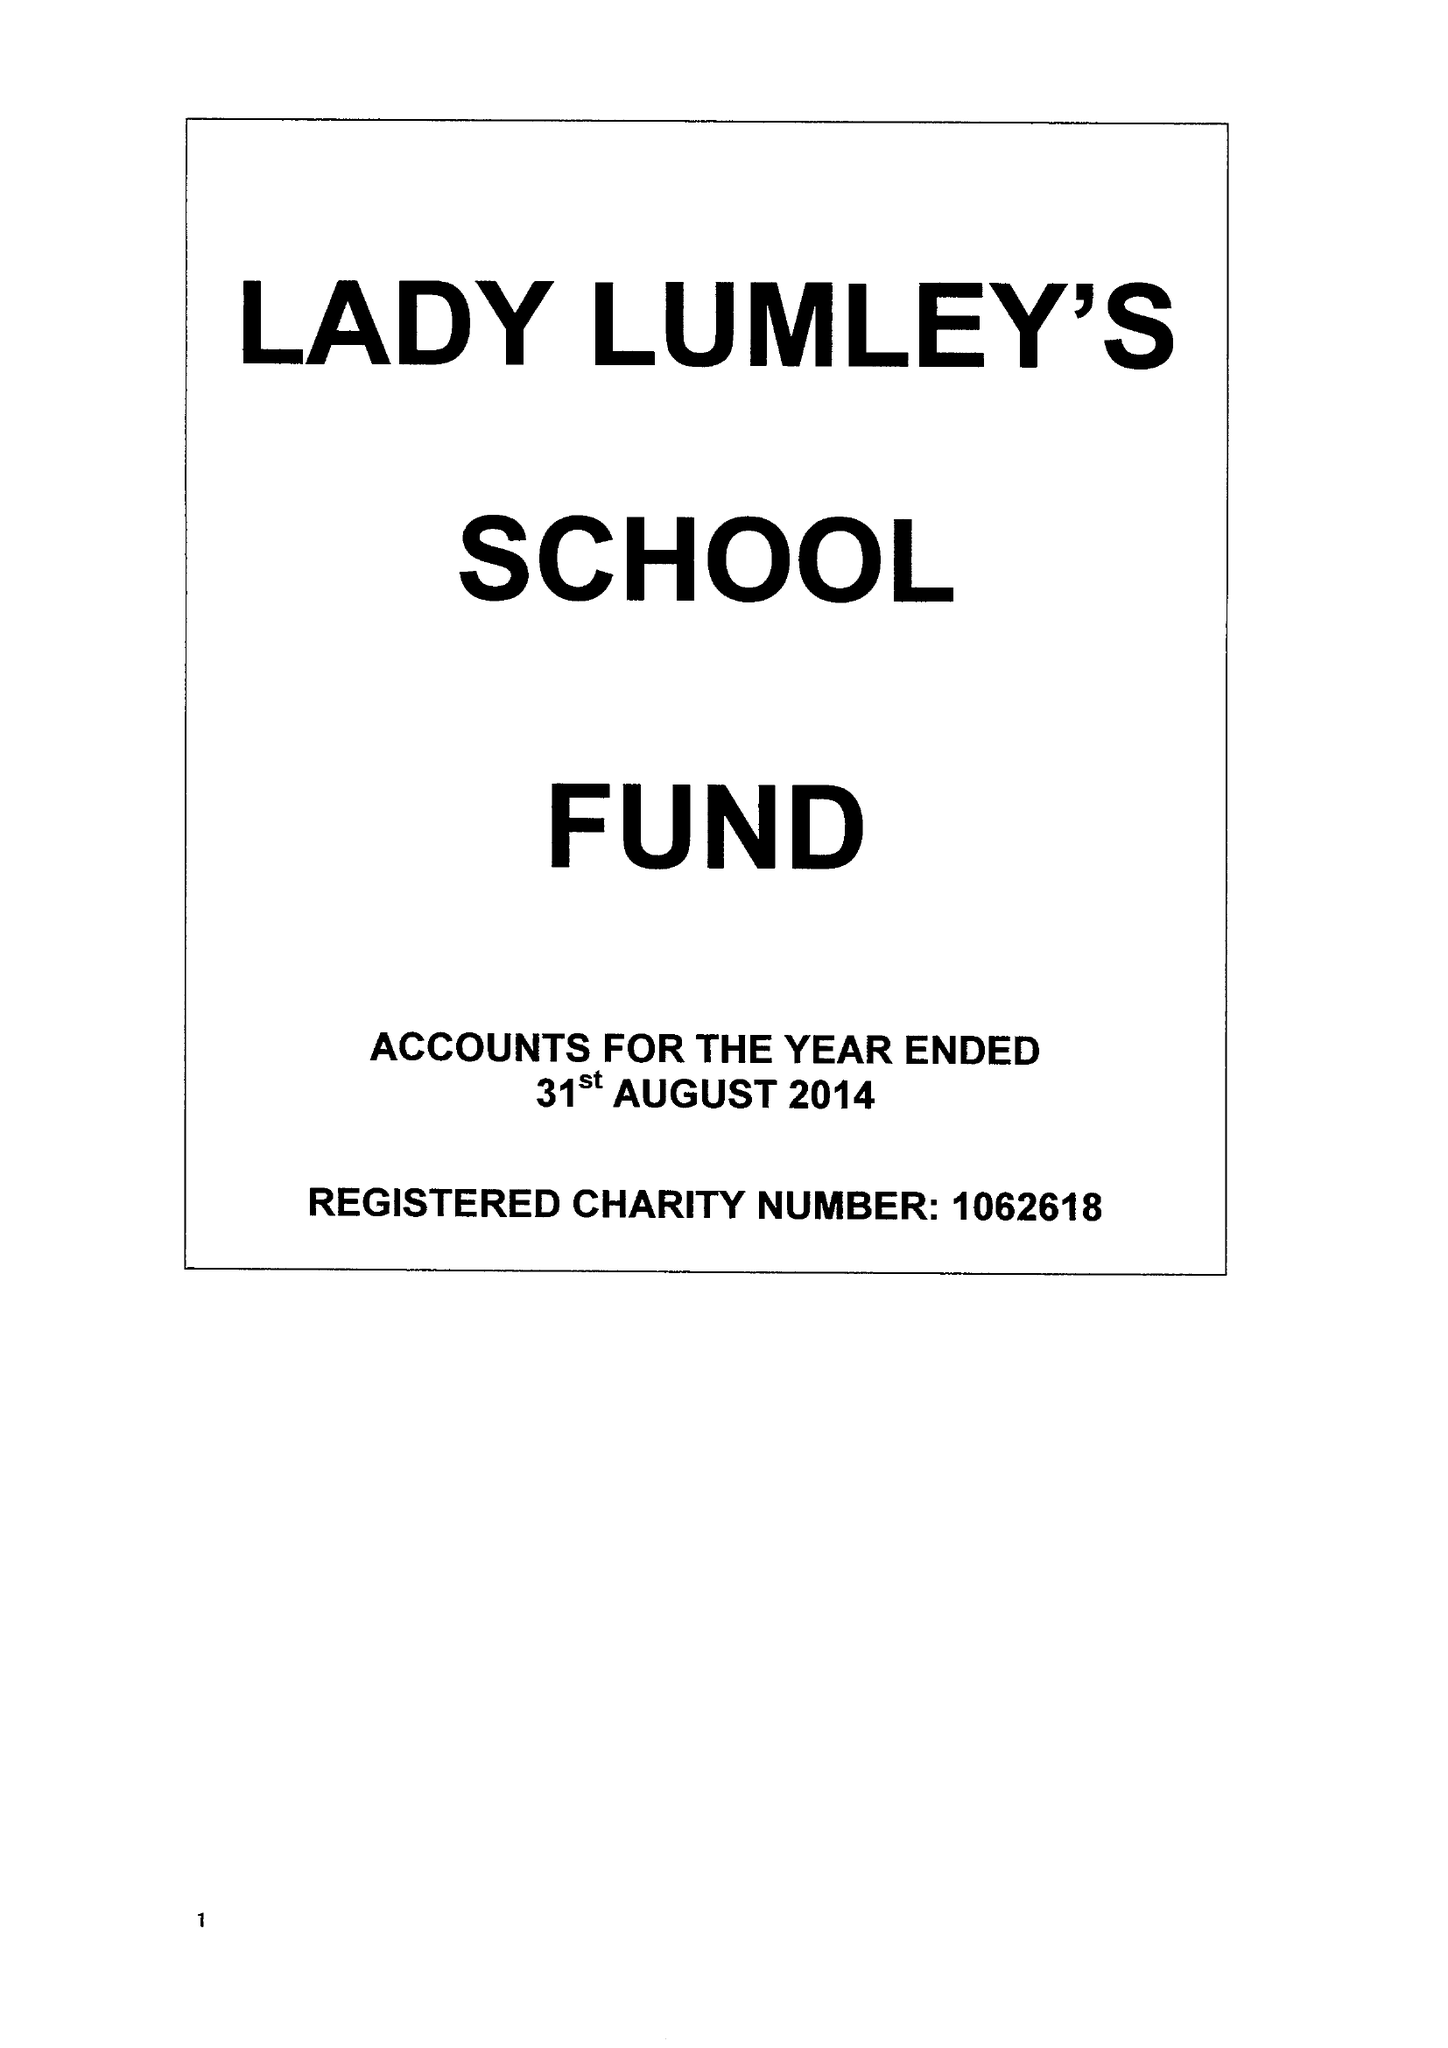What is the value for the address__street_line?
Answer the question using a single word or phrase. SWAINSEA LANE 